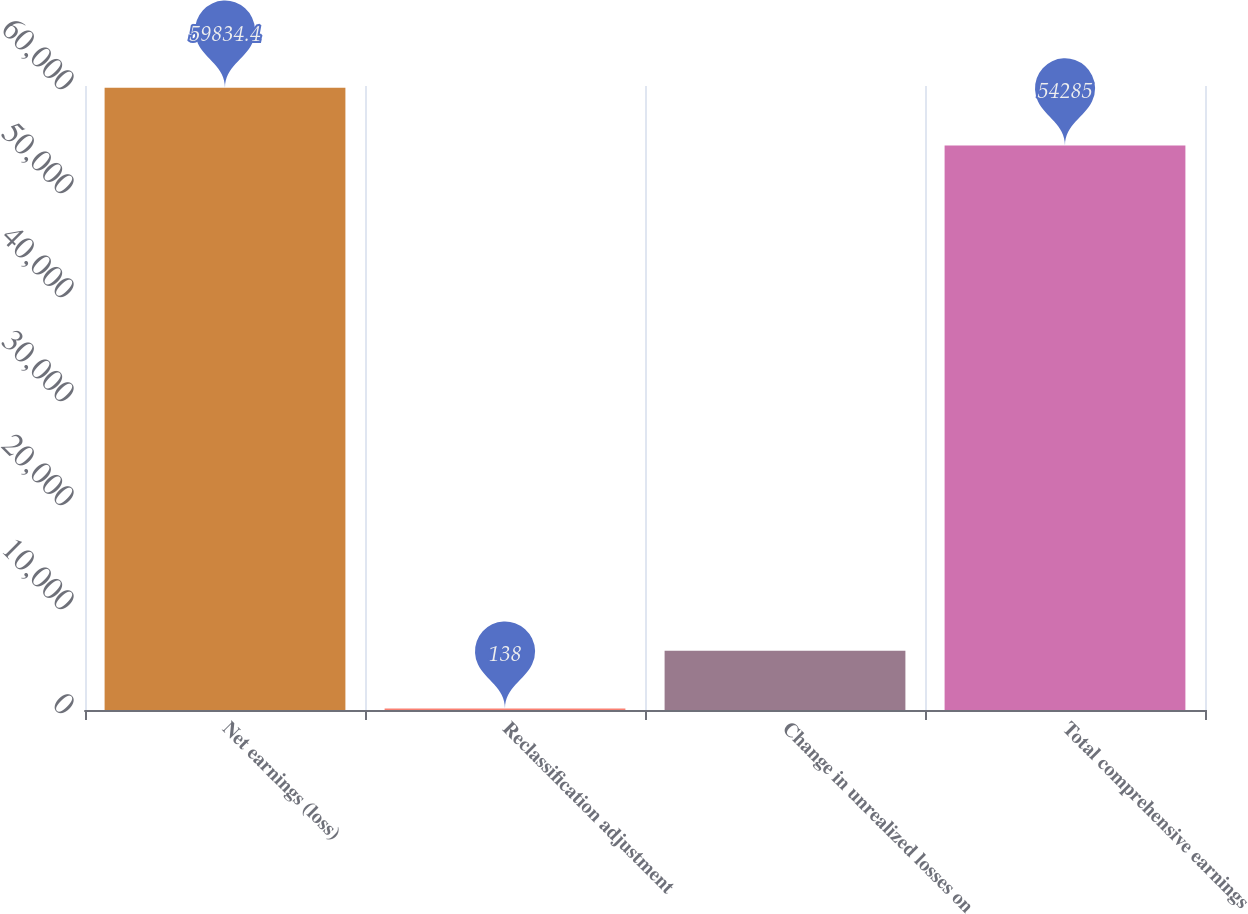Convert chart. <chart><loc_0><loc_0><loc_500><loc_500><bar_chart><fcel>Net earnings (loss)<fcel>Reclassification adjustment<fcel>Change in unrealized losses on<fcel>Total comprehensive earnings<nl><fcel>59834.4<fcel>138<fcel>5687.4<fcel>54285<nl></chart> 